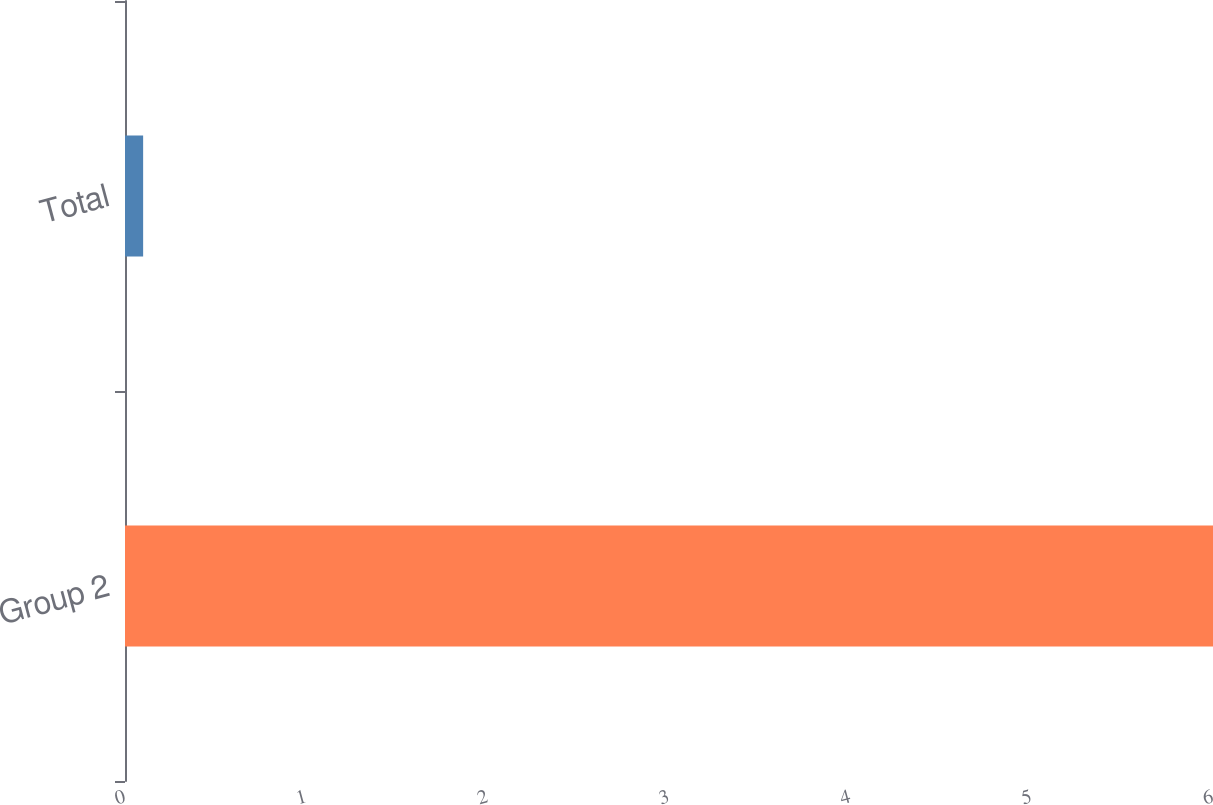Convert chart to OTSL. <chart><loc_0><loc_0><loc_500><loc_500><bar_chart><fcel>Group 2<fcel>Total<nl><fcel>6<fcel>0.1<nl></chart> 